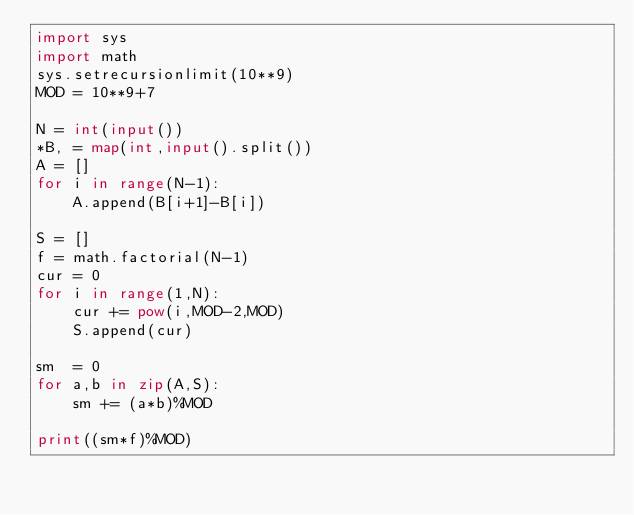<code> <loc_0><loc_0><loc_500><loc_500><_Python_>import sys
import math
sys.setrecursionlimit(10**9)
MOD = 10**9+7

N = int(input())
*B, = map(int,input().split())
A = []
for i in range(N-1):
    A.append(B[i+1]-B[i])

S = []
f = math.factorial(N-1)
cur = 0
for i in range(1,N):
    cur += pow(i,MOD-2,MOD)
    S.append(cur)

sm  = 0
for a,b in zip(A,S):
    sm += (a*b)%MOD

print((sm*f)%MOD)</code> 